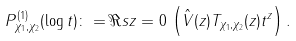<formula> <loc_0><loc_0><loc_500><loc_500>P _ { \chi _ { 1 } , \chi _ { 2 } } ^ { ( 1 ) } ( \log t ) \colon = \Re s { z = 0 } \, \left ( \hat { V } ( z ) T _ { \chi _ { 1 } , \chi _ { 2 } } ( z ) t ^ { z } \right ) .</formula> 